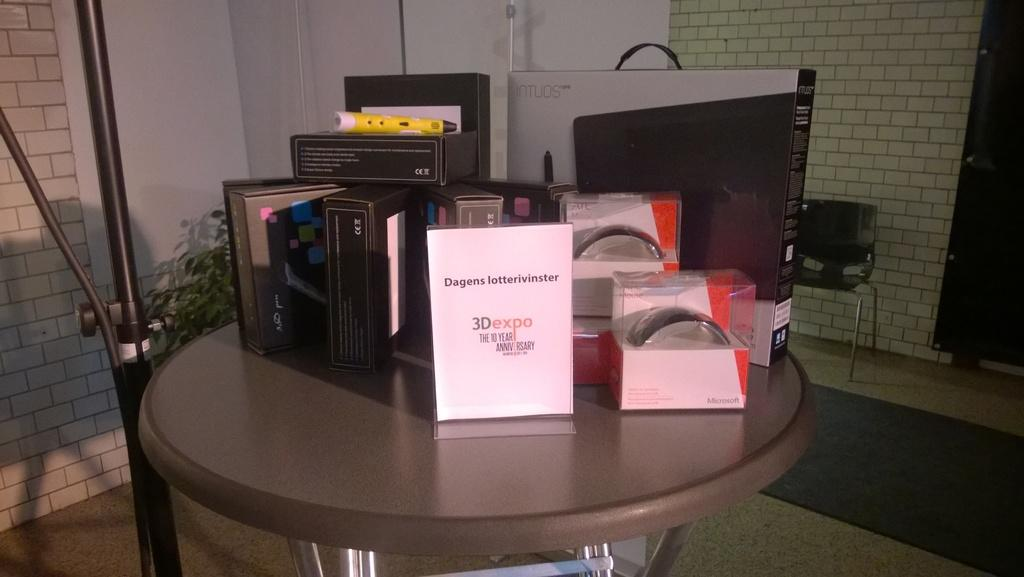<image>
Give a short and clear explanation of the subsequent image. Several boxes for electronics with the white sign dagens lottervinster on the center. 